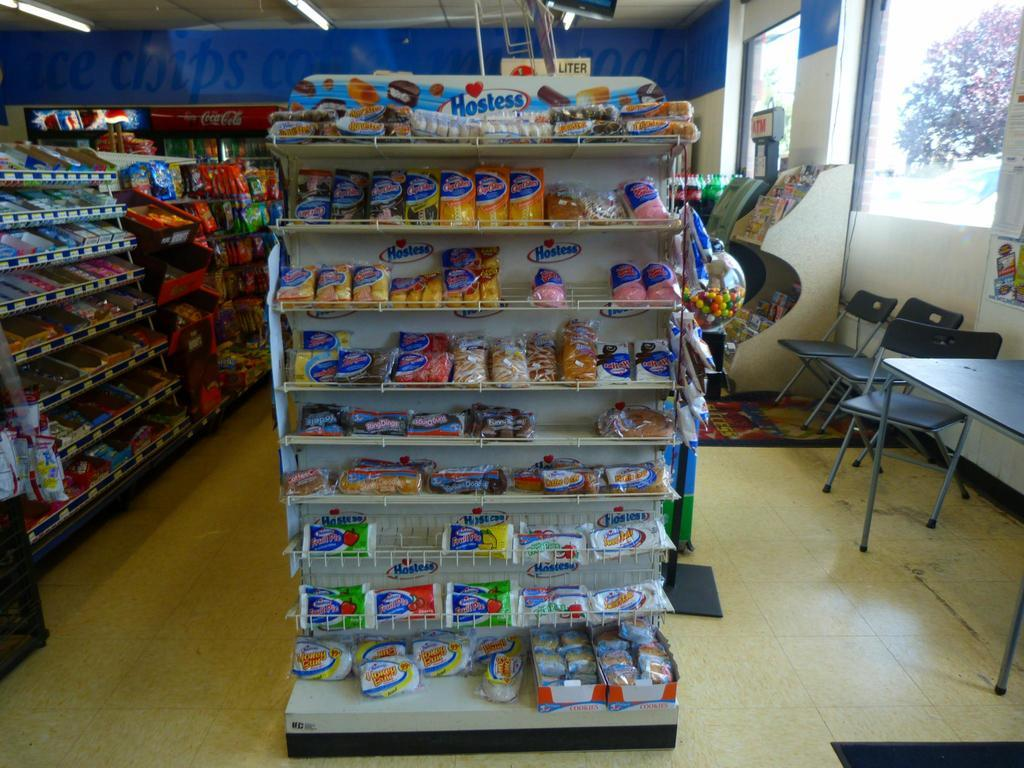<image>
Provide a brief description of the given image. A gas station with a display reading Hostess that includes various hostess prodducts. 